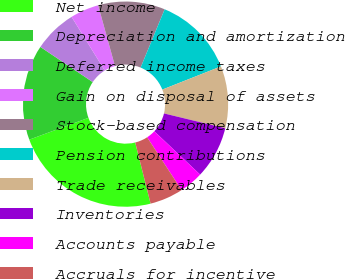Convert chart to OTSL. <chart><loc_0><loc_0><loc_500><loc_500><pie_chart><fcel>Net income<fcel>Depreciation and amortization<fcel>Deferred income taxes<fcel>Gain on disposal of assets<fcel>Stock-based compensation<fcel>Pension contributions<fcel>Trade receivables<fcel>Inventories<fcel>Accounts payable<fcel>Accruals for incentive<nl><fcel>23.3%<fcel>15.04%<fcel>6.77%<fcel>4.51%<fcel>10.53%<fcel>12.78%<fcel>9.77%<fcel>8.27%<fcel>3.76%<fcel>5.27%<nl></chart> 